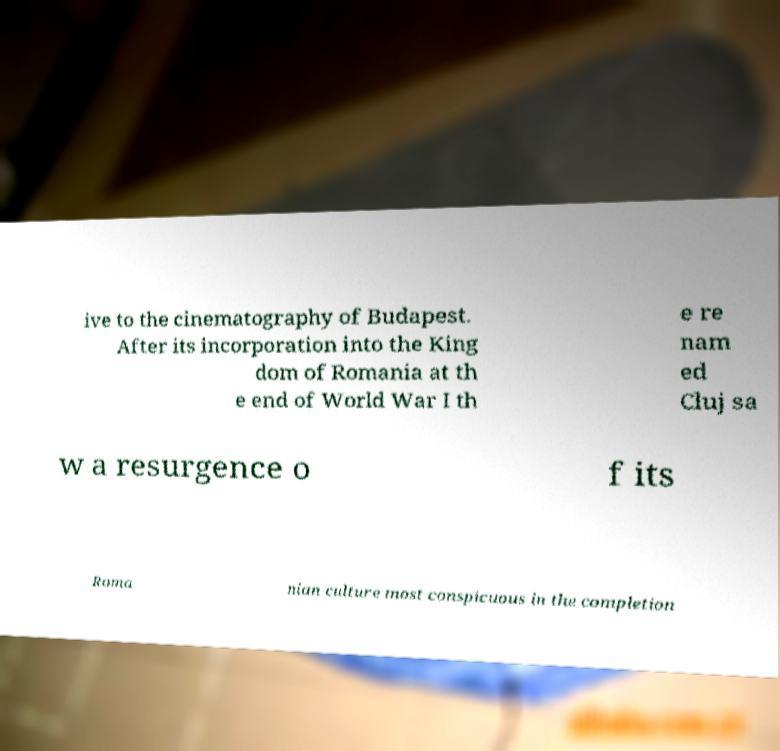What messages or text are displayed in this image? I need them in a readable, typed format. ive to the cinematography of Budapest. After its incorporation into the King dom of Romania at th e end of World War I th e re nam ed Cluj sa w a resurgence o f its Roma nian culture most conspicuous in the completion 